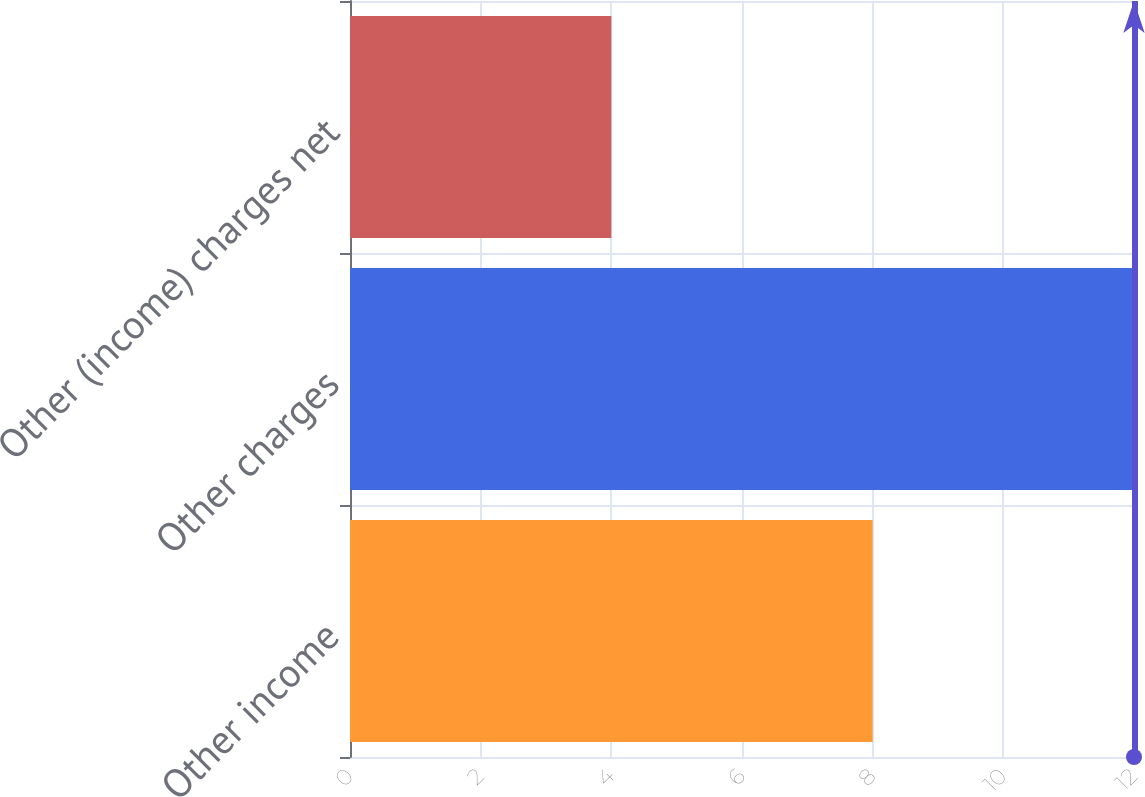Convert chart. <chart><loc_0><loc_0><loc_500><loc_500><bar_chart><fcel>Other income<fcel>Other charges<fcel>Other (income) charges net<nl><fcel>8<fcel>12<fcel>4<nl></chart> 